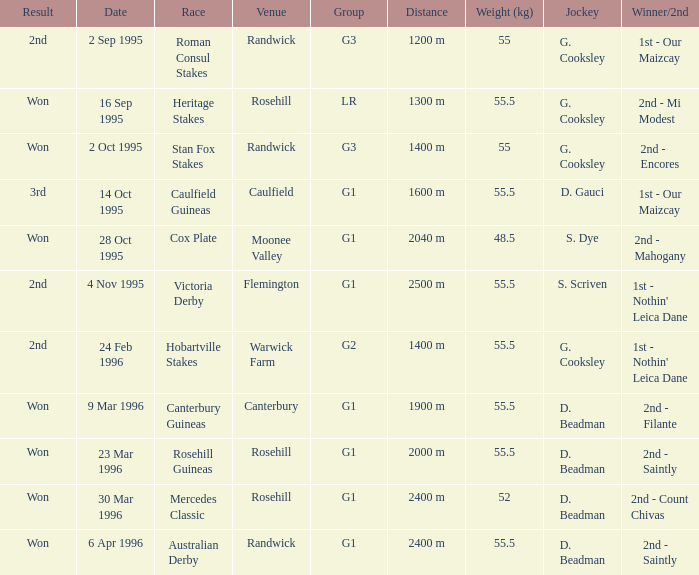Which location was the site for the stan fox stakes event? Randwick. 